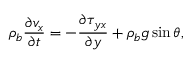<formula> <loc_0><loc_0><loc_500><loc_500>\rho _ { b } \frac { \partial v _ { x } } { \partial t } = - \frac { \partial \tau _ { y x } } { \partial y } + \rho _ { b } g \sin \theta ,</formula> 